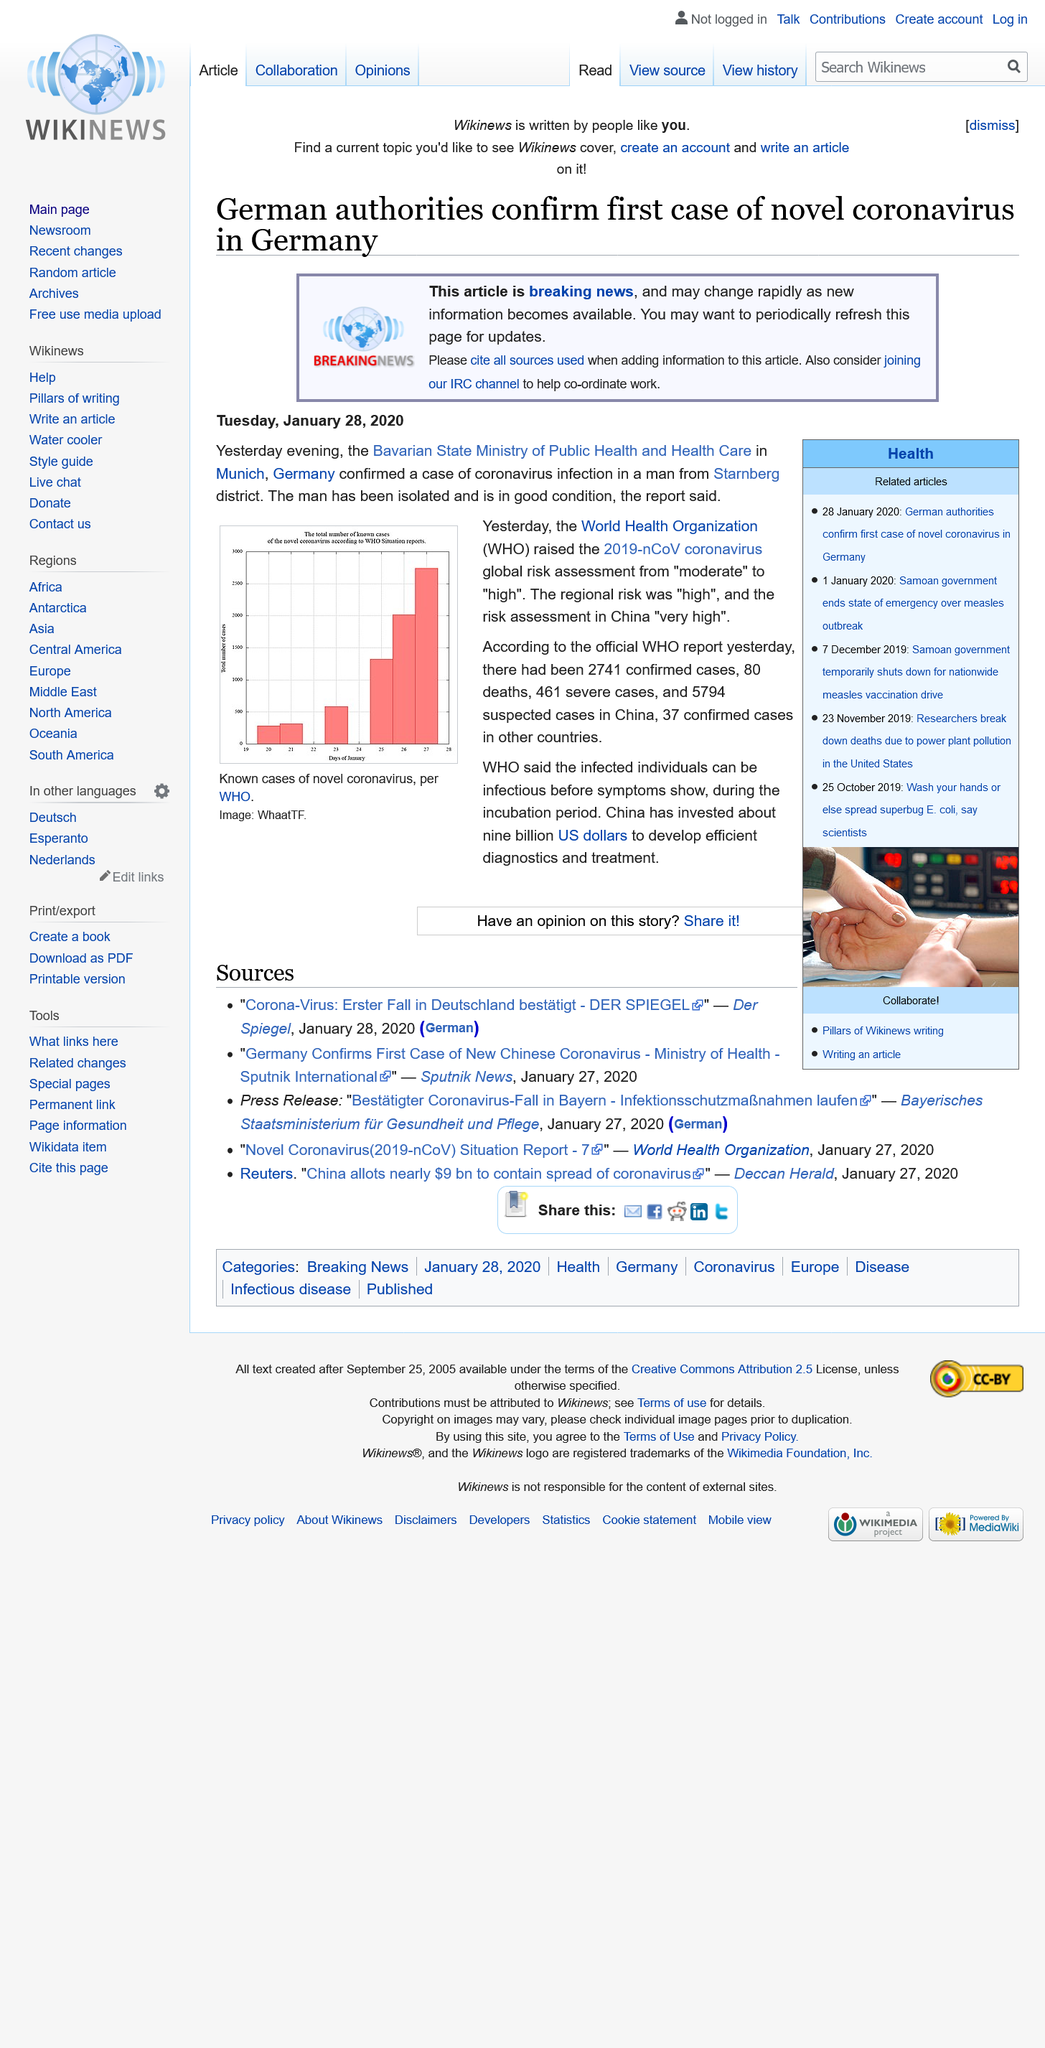Outline some significant characteristics in this image. China has invested approximately nine billion US dollars to develop efficient diagnostics and treatment. Eighty people have died of the coronavirus according to the official WHO report. The graph displays information from January. 